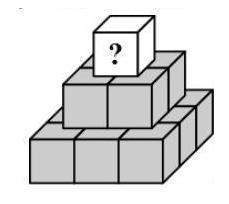Can you explain how the pyramid's structure influences the placement of numbers for obtaining the maximum sum at the top? Certainly! The pyramid's layered structure means each higher level cube's value is determined by the sum of the four cubes directly below it. Therefore, to maximize the top cube's number, you would allocate the smallest numbers possible at the base, subsequently increasing the numbers as you move up. This placement ensures each cube sums to the highest number achievable from the set of numbers on the cubes beneath it. 